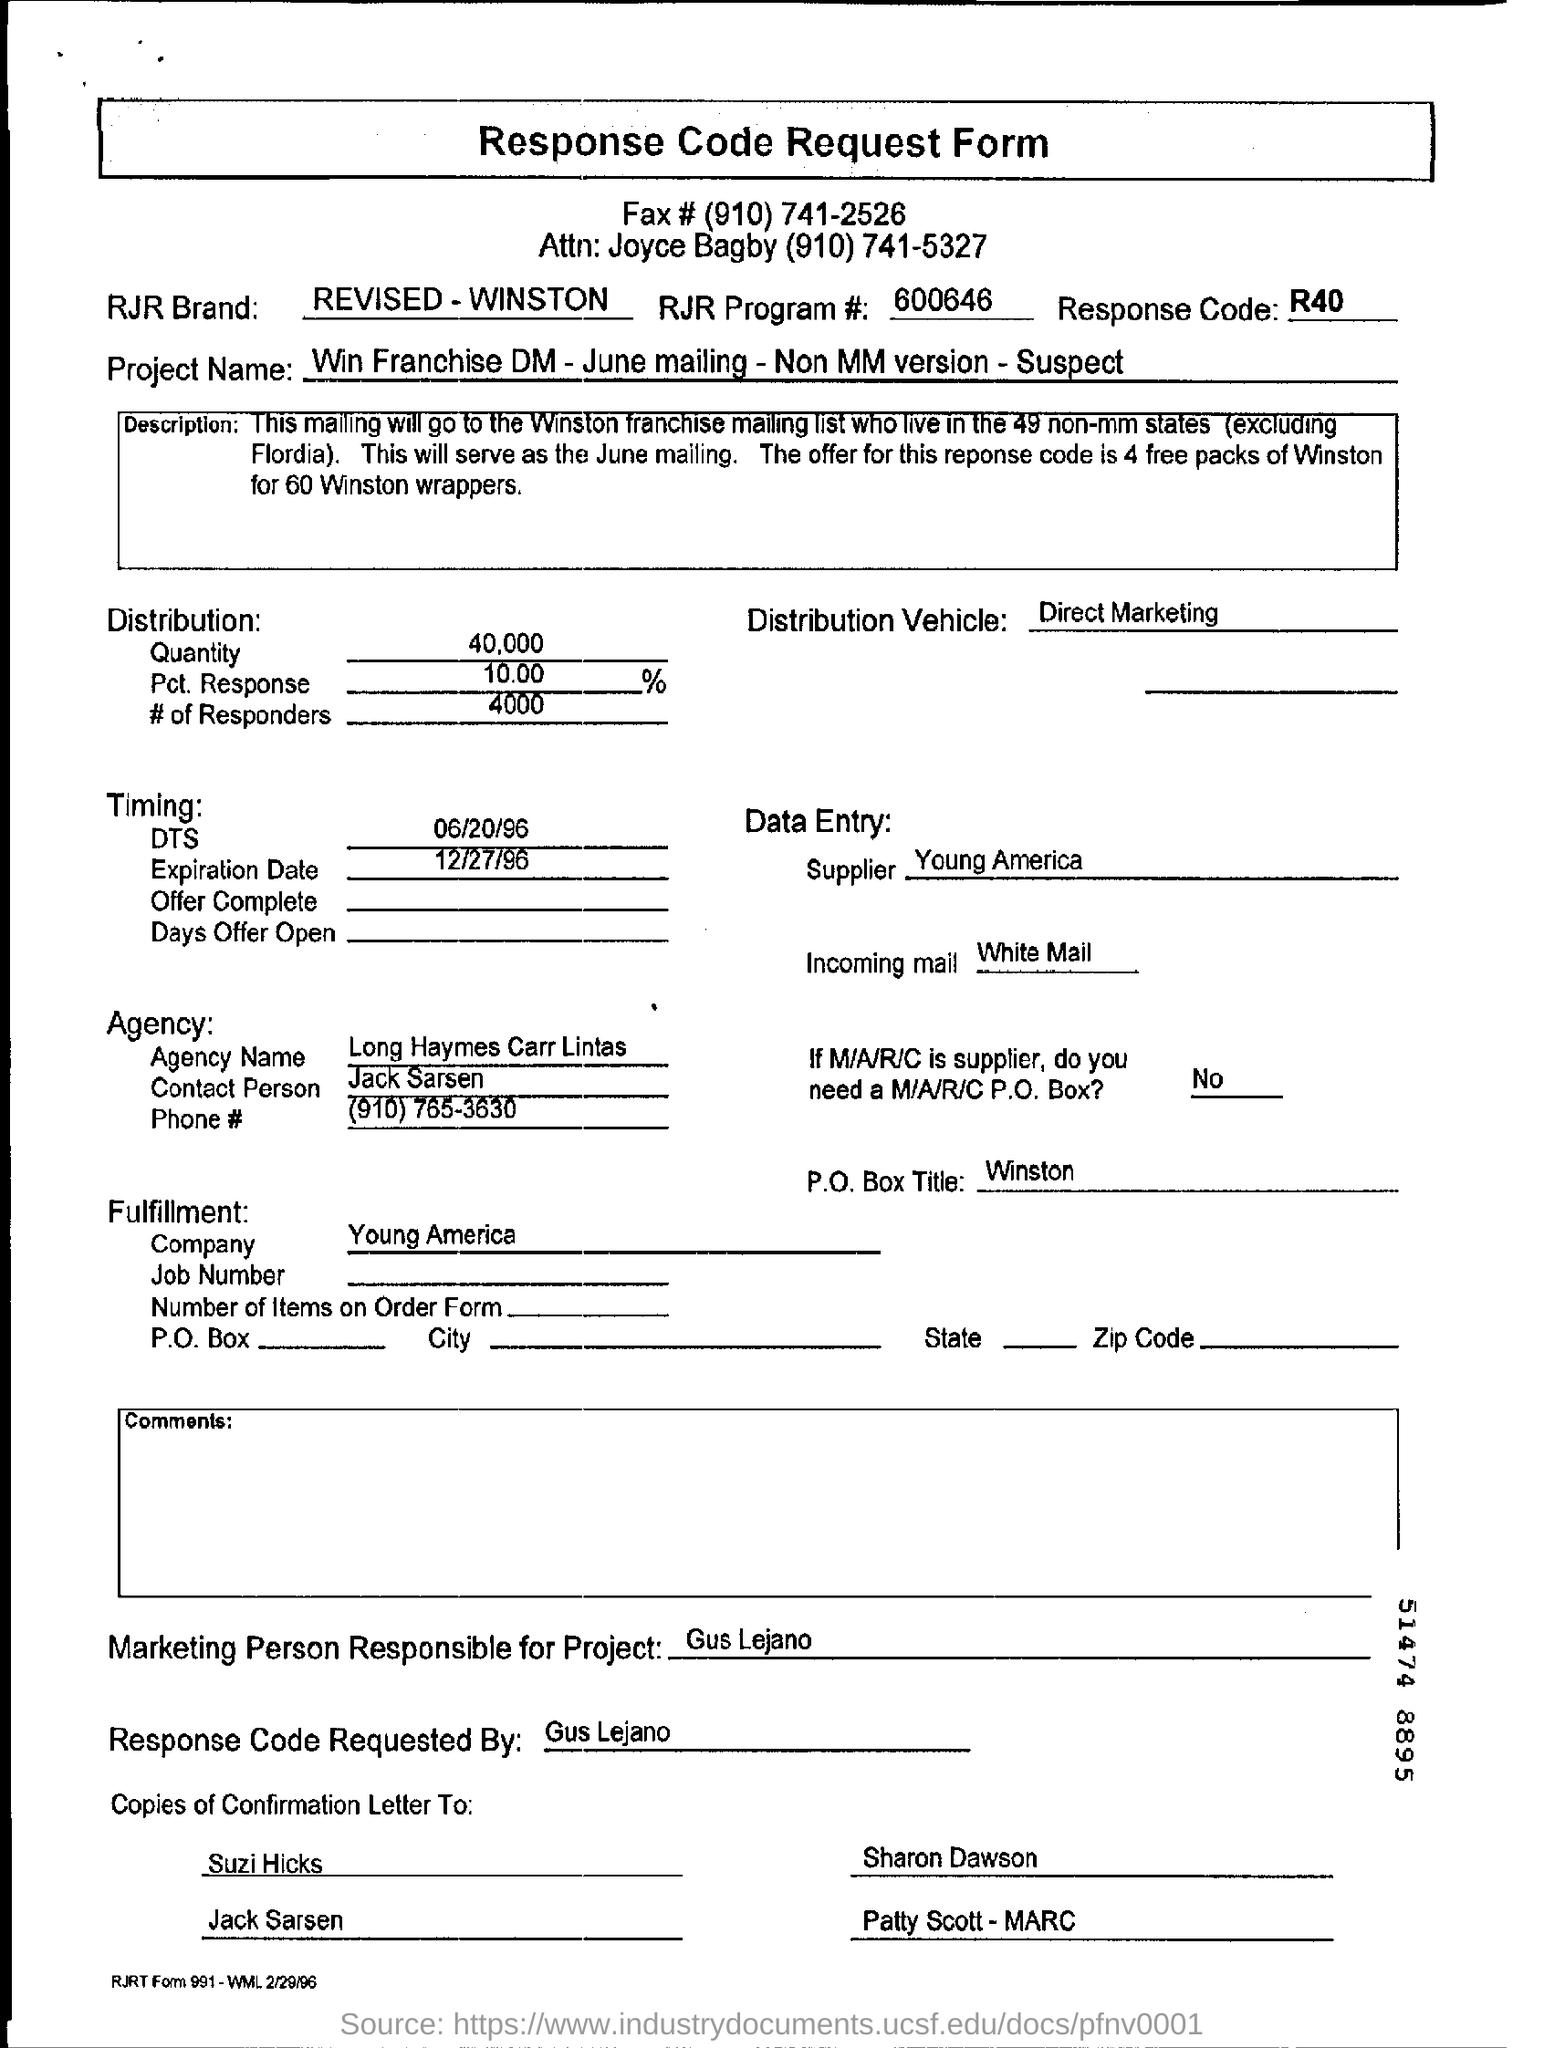What is the project name ?
Give a very brief answer. Win Franchise DM - June mailing - Non MM version - Suspect. What is the Response code ?
Provide a succinct answer. R40 . What is RJR program number ?
Ensure brevity in your answer.  600646. Who is the marketing person responsible for this ?
Your answer should be compact. Gus lejano. Response code was requested by ?
Your response must be concise. Gus Lejano . 